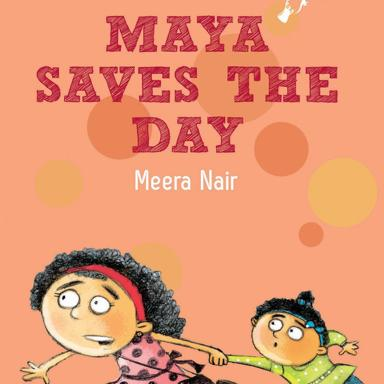Can you describe the visual content of the image? The image depicts the cover of a children's book titled 'Maya Saves The Day' by Meera Nair. On the cover, we see two cartoon characters: a young girl with curly hair, wearing a pink and black patterned dress, and a smaller child in a green and yellow outfit. They appear to be in a rush, with the older girl pulling the younger one along. A sense of urgency is conveyed through their dynamic poses and expressions. The background is a warm orange, punctuated with lighter circles that suggest a playful, energetic atmosphere. 